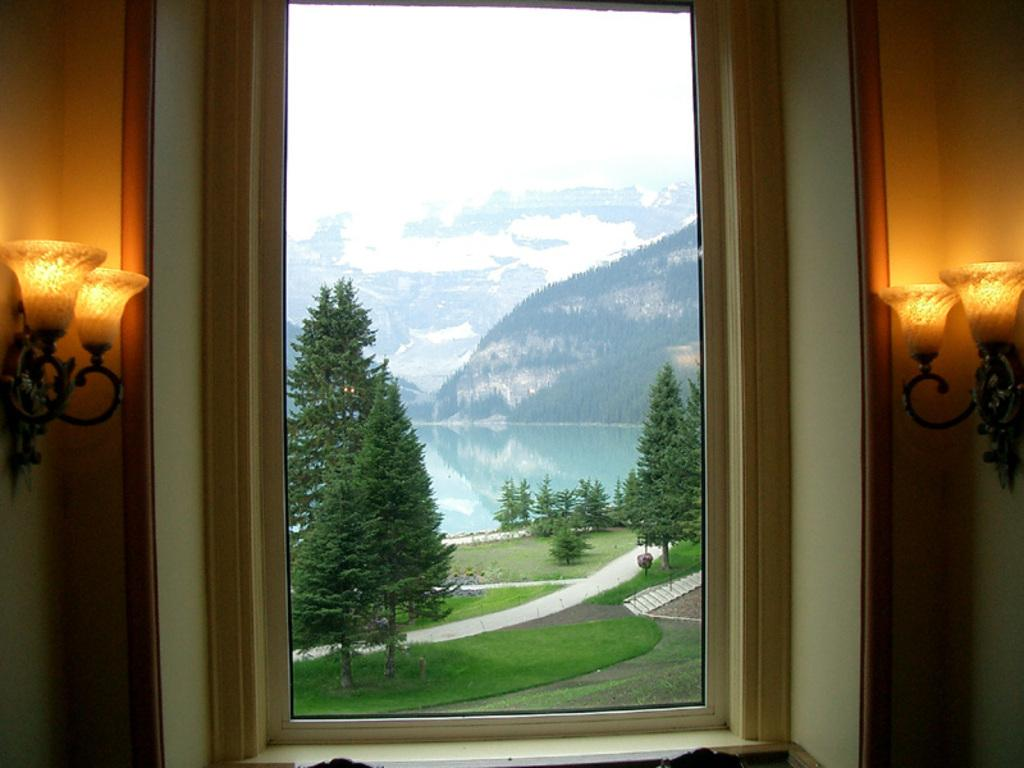What type of vegetation can be seen through the window in the image? Trees are visible through the window in the image. What natural element can also be seen through the window? Water is visible through the window in the image. What type of ground cover is visible through the window? Grass is visible through the window in the image. What artificial light source is present in the image? There are lights on the wall in the image. What type of tin can be seen through the window in the image? There is no tin present in the image. Is there any indication of a wound on any of the objects in the image? There is no indication of a wound on any of the objects in the image. 